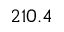<formula> <loc_0><loc_0><loc_500><loc_500>2 1 0 . 4</formula> 